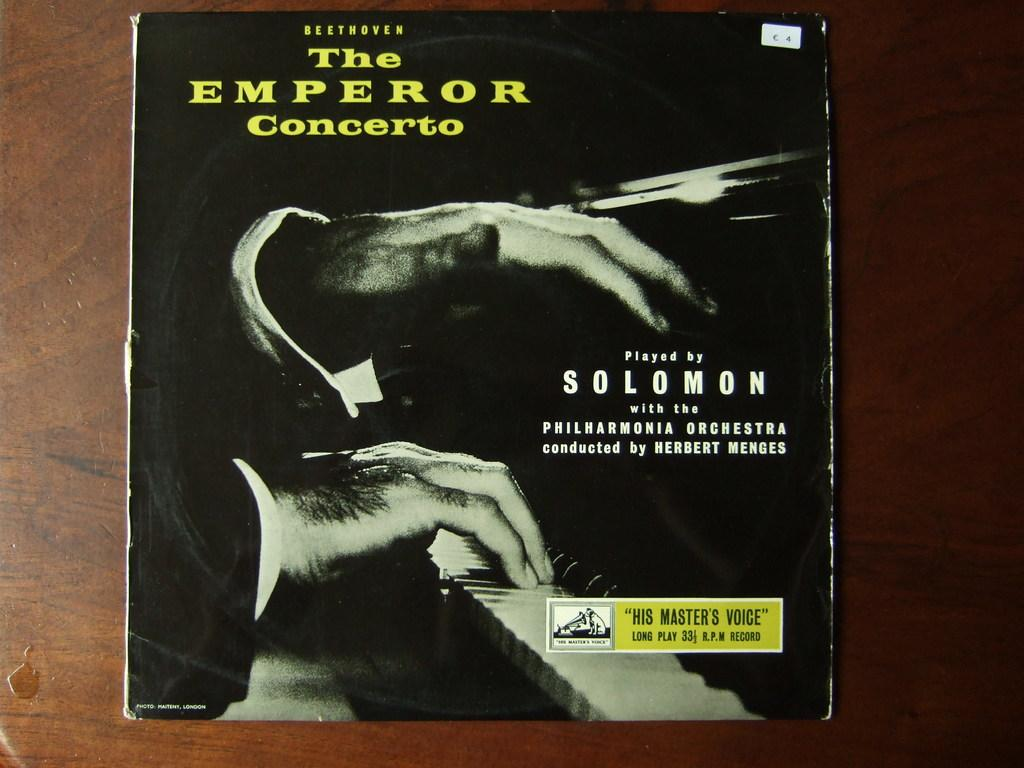<image>
Create a compact narrative representing the image presented. A black CD cover titled the Emperor Concerto. 